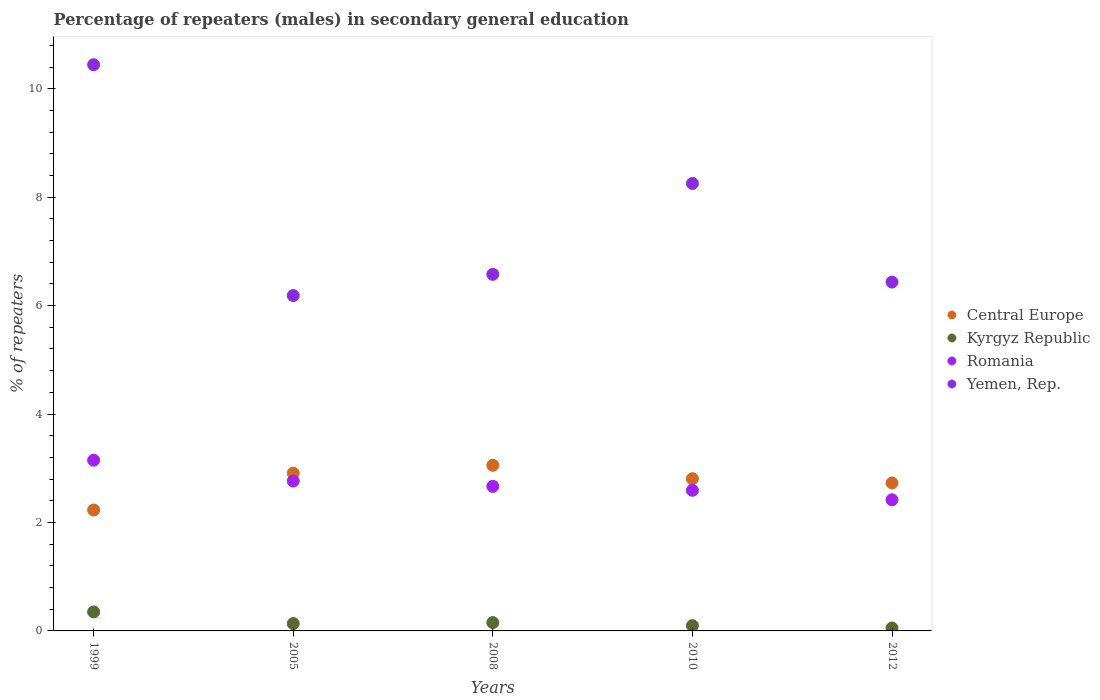What is the percentage of male repeaters in Yemen, Rep. in 2010?
Offer a terse response. 8.25. Across all years, what is the maximum percentage of male repeaters in Kyrgyz Republic?
Your answer should be very brief. 0.35. Across all years, what is the minimum percentage of male repeaters in Central Europe?
Keep it short and to the point. 2.23. In which year was the percentage of male repeaters in Central Europe maximum?
Ensure brevity in your answer.  2008. In which year was the percentage of male repeaters in Central Europe minimum?
Offer a very short reply. 1999. What is the total percentage of male repeaters in Central Europe in the graph?
Offer a terse response. 13.73. What is the difference between the percentage of male repeaters in Romania in 2008 and that in 2010?
Your answer should be very brief. 0.07. What is the difference between the percentage of male repeaters in Romania in 1999 and the percentage of male repeaters in Kyrgyz Republic in 2008?
Your answer should be compact. 3. What is the average percentage of male repeaters in Yemen, Rep. per year?
Ensure brevity in your answer.  7.58. In the year 2008, what is the difference between the percentage of male repeaters in Central Europe and percentage of male repeaters in Kyrgyz Republic?
Your answer should be compact. 2.9. In how many years, is the percentage of male repeaters in Yemen, Rep. greater than 7.6 %?
Make the answer very short. 2. What is the ratio of the percentage of male repeaters in Romania in 1999 to that in 2012?
Your answer should be compact. 1.3. Is the percentage of male repeaters in Kyrgyz Republic in 1999 less than that in 2012?
Make the answer very short. No. Is the difference between the percentage of male repeaters in Central Europe in 2010 and 2012 greater than the difference between the percentage of male repeaters in Kyrgyz Republic in 2010 and 2012?
Ensure brevity in your answer.  Yes. What is the difference between the highest and the second highest percentage of male repeaters in Kyrgyz Republic?
Make the answer very short. 0.2. What is the difference between the highest and the lowest percentage of male repeaters in Romania?
Provide a short and direct response. 0.73. In how many years, is the percentage of male repeaters in Kyrgyz Republic greater than the average percentage of male repeaters in Kyrgyz Republic taken over all years?
Give a very brief answer. 1. How many dotlines are there?
Provide a short and direct response. 4. Are the values on the major ticks of Y-axis written in scientific E-notation?
Give a very brief answer. No. Where does the legend appear in the graph?
Your response must be concise. Center right. How many legend labels are there?
Give a very brief answer. 4. What is the title of the graph?
Ensure brevity in your answer.  Percentage of repeaters (males) in secondary general education. What is the label or title of the X-axis?
Your answer should be compact. Years. What is the label or title of the Y-axis?
Make the answer very short. % of repeaters. What is the % of repeaters in Central Europe in 1999?
Give a very brief answer. 2.23. What is the % of repeaters of Kyrgyz Republic in 1999?
Provide a succinct answer. 0.35. What is the % of repeaters in Romania in 1999?
Your answer should be compact. 3.15. What is the % of repeaters in Yemen, Rep. in 1999?
Make the answer very short. 10.44. What is the % of repeaters of Central Europe in 2005?
Make the answer very short. 2.91. What is the % of repeaters of Kyrgyz Republic in 2005?
Your answer should be compact. 0.14. What is the % of repeaters in Romania in 2005?
Your answer should be compact. 2.76. What is the % of repeaters of Yemen, Rep. in 2005?
Offer a terse response. 6.19. What is the % of repeaters of Central Europe in 2008?
Keep it short and to the point. 3.05. What is the % of repeaters of Kyrgyz Republic in 2008?
Give a very brief answer. 0.15. What is the % of repeaters in Romania in 2008?
Your answer should be compact. 2.67. What is the % of repeaters in Yemen, Rep. in 2008?
Give a very brief answer. 6.58. What is the % of repeaters of Central Europe in 2010?
Your answer should be very brief. 2.81. What is the % of repeaters in Kyrgyz Republic in 2010?
Give a very brief answer. 0.1. What is the % of repeaters in Romania in 2010?
Your answer should be very brief. 2.59. What is the % of repeaters in Yemen, Rep. in 2010?
Your answer should be very brief. 8.25. What is the % of repeaters in Central Europe in 2012?
Your answer should be compact. 2.73. What is the % of repeaters of Kyrgyz Republic in 2012?
Provide a succinct answer. 0.05. What is the % of repeaters of Romania in 2012?
Provide a short and direct response. 2.42. What is the % of repeaters of Yemen, Rep. in 2012?
Your answer should be compact. 6.43. Across all years, what is the maximum % of repeaters of Central Europe?
Your answer should be compact. 3.05. Across all years, what is the maximum % of repeaters in Kyrgyz Republic?
Offer a terse response. 0.35. Across all years, what is the maximum % of repeaters of Romania?
Give a very brief answer. 3.15. Across all years, what is the maximum % of repeaters in Yemen, Rep.?
Give a very brief answer. 10.44. Across all years, what is the minimum % of repeaters in Central Europe?
Offer a very short reply. 2.23. Across all years, what is the minimum % of repeaters in Kyrgyz Republic?
Your response must be concise. 0.05. Across all years, what is the minimum % of repeaters in Romania?
Offer a very short reply. 2.42. Across all years, what is the minimum % of repeaters in Yemen, Rep.?
Your answer should be compact. 6.19. What is the total % of repeaters in Central Europe in the graph?
Provide a succinct answer. 13.73. What is the total % of repeaters in Kyrgyz Republic in the graph?
Make the answer very short. 0.79. What is the total % of repeaters in Romania in the graph?
Ensure brevity in your answer.  13.59. What is the total % of repeaters of Yemen, Rep. in the graph?
Provide a succinct answer. 37.89. What is the difference between the % of repeaters of Central Europe in 1999 and that in 2005?
Provide a short and direct response. -0.68. What is the difference between the % of repeaters of Kyrgyz Republic in 1999 and that in 2005?
Keep it short and to the point. 0.22. What is the difference between the % of repeaters of Romania in 1999 and that in 2005?
Offer a terse response. 0.39. What is the difference between the % of repeaters in Yemen, Rep. in 1999 and that in 2005?
Your response must be concise. 4.26. What is the difference between the % of repeaters in Central Europe in 1999 and that in 2008?
Keep it short and to the point. -0.83. What is the difference between the % of repeaters in Kyrgyz Republic in 1999 and that in 2008?
Provide a short and direct response. 0.2. What is the difference between the % of repeaters of Romania in 1999 and that in 2008?
Give a very brief answer. 0.48. What is the difference between the % of repeaters of Yemen, Rep. in 1999 and that in 2008?
Your answer should be very brief. 3.87. What is the difference between the % of repeaters of Central Europe in 1999 and that in 2010?
Provide a succinct answer. -0.58. What is the difference between the % of repeaters in Kyrgyz Republic in 1999 and that in 2010?
Provide a succinct answer. 0.25. What is the difference between the % of repeaters in Romania in 1999 and that in 2010?
Ensure brevity in your answer.  0.56. What is the difference between the % of repeaters of Yemen, Rep. in 1999 and that in 2010?
Your answer should be very brief. 2.19. What is the difference between the % of repeaters in Central Europe in 1999 and that in 2012?
Your answer should be very brief. -0.5. What is the difference between the % of repeaters in Kyrgyz Republic in 1999 and that in 2012?
Keep it short and to the point. 0.3. What is the difference between the % of repeaters of Romania in 1999 and that in 2012?
Your response must be concise. 0.73. What is the difference between the % of repeaters in Yemen, Rep. in 1999 and that in 2012?
Your response must be concise. 4.01. What is the difference between the % of repeaters of Central Europe in 2005 and that in 2008?
Offer a terse response. -0.15. What is the difference between the % of repeaters of Kyrgyz Republic in 2005 and that in 2008?
Your answer should be very brief. -0.02. What is the difference between the % of repeaters in Romania in 2005 and that in 2008?
Ensure brevity in your answer.  0.1. What is the difference between the % of repeaters in Yemen, Rep. in 2005 and that in 2008?
Your response must be concise. -0.39. What is the difference between the % of repeaters in Central Europe in 2005 and that in 2010?
Your answer should be very brief. 0.1. What is the difference between the % of repeaters of Kyrgyz Republic in 2005 and that in 2010?
Make the answer very short. 0.04. What is the difference between the % of repeaters in Romania in 2005 and that in 2010?
Provide a short and direct response. 0.17. What is the difference between the % of repeaters of Yemen, Rep. in 2005 and that in 2010?
Offer a terse response. -2.07. What is the difference between the % of repeaters in Central Europe in 2005 and that in 2012?
Provide a succinct answer. 0.18. What is the difference between the % of repeaters in Kyrgyz Republic in 2005 and that in 2012?
Your response must be concise. 0.08. What is the difference between the % of repeaters of Romania in 2005 and that in 2012?
Provide a short and direct response. 0.34. What is the difference between the % of repeaters in Yemen, Rep. in 2005 and that in 2012?
Your answer should be compact. -0.25. What is the difference between the % of repeaters in Central Europe in 2008 and that in 2010?
Your answer should be compact. 0.25. What is the difference between the % of repeaters in Kyrgyz Republic in 2008 and that in 2010?
Your response must be concise. 0.06. What is the difference between the % of repeaters of Romania in 2008 and that in 2010?
Provide a succinct answer. 0.07. What is the difference between the % of repeaters of Yemen, Rep. in 2008 and that in 2010?
Keep it short and to the point. -1.68. What is the difference between the % of repeaters in Central Europe in 2008 and that in 2012?
Your answer should be very brief. 0.33. What is the difference between the % of repeaters in Kyrgyz Republic in 2008 and that in 2012?
Make the answer very short. 0.1. What is the difference between the % of repeaters of Romania in 2008 and that in 2012?
Ensure brevity in your answer.  0.25. What is the difference between the % of repeaters of Yemen, Rep. in 2008 and that in 2012?
Ensure brevity in your answer.  0.14. What is the difference between the % of repeaters in Central Europe in 2010 and that in 2012?
Provide a short and direct response. 0.08. What is the difference between the % of repeaters of Kyrgyz Republic in 2010 and that in 2012?
Give a very brief answer. 0.04. What is the difference between the % of repeaters of Romania in 2010 and that in 2012?
Your answer should be very brief. 0.17. What is the difference between the % of repeaters in Yemen, Rep. in 2010 and that in 2012?
Your answer should be very brief. 1.82. What is the difference between the % of repeaters in Central Europe in 1999 and the % of repeaters in Kyrgyz Republic in 2005?
Keep it short and to the point. 2.09. What is the difference between the % of repeaters of Central Europe in 1999 and the % of repeaters of Romania in 2005?
Give a very brief answer. -0.53. What is the difference between the % of repeaters in Central Europe in 1999 and the % of repeaters in Yemen, Rep. in 2005?
Give a very brief answer. -3.96. What is the difference between the % of repeaters in Kyrgyz Republic in 1999 and the % of repeaters in Romania in 2005?
Give a very brief answer. -2.41. What is the difference between the % of repeaters in Kyrgyz Republic in 1999 and the % of repeaters in Yemen, Rep. in 2005?
Provide a succinct answer. -5.84. What is the difference between the % of repeaters in Romania in 1999 and the % of repeaters in Yemen, Rep. in 2005?
Give a very brief answer. -3.04. What is the difference between the % of repeaters in Central Europe in 1999 and the % of repeaters in Kyrgyz Republic in 2008?
Ensure brevity in your answer.  2.08. What is the difference between the % of repeaters of Central Europe in 1999 and the % of repeaters of Romania in 2008?
Ensure brevity in your answer.  -0.44. What is the difference between the % of repeaters of Central Europe in 1999 and the % of repeaters of Yemen, Rep. in 2008?
Provide a short and direct response. -4.35. What is the difference between the % of repeaters in Kyrgyz Republic in 1999 and the % of repeaters in Romania in 2008?
Provide a succinct answer. -2.32. What is the difference between the % of repeaters of Kyrgyz Republic in 1999 and the % of repeaters of Yemen, Rep. in 2008?
Your answer should be compact. -6.23. What is the difference between the % of repeaters of Romania in 1999 and the % of repeaters of Yemen, Rep. in 2008?
Give a very brief answer. -3.43. What is the difference between the % of repeaters of Central Europe in 1999 and the % of repeaters of Kyrgyz Republic in 2010?
Ensure brevity in your answer.  2.13. What is the difference between the % of repeaters of Central Europe in 1999 and the % of repeaters of Romania in 2010?
Make the answer very short. -0.36. What is the difference between the % of repeaters of Central Europe in 1999 and the % of repeaters of Yemen, Rep. in 2010?
Ensure brevity in your answer.  -6.02. What is the difference between the % of repeaters of Kyrgyz Republic in 1999 and the % of repeaters of Romania in 2010?
Make the answer very short. -2.24. What is the difference between the % of repeaters of Kyrgyz Republic in 1999 and the % of repeaters of Yemen, Rep. in 2010?
Provide a short and direct response. -7.9. What is the difference between the % of repeaters of Romania in 1999 and the % of repeaters of Yemen, Rep. in 2010?
Offer a very short reply. -5.1. What is the difference between the % of repeaters of Central Europe in 1999 and the % of repeaters of Kyrgyz Republic in 2012?
Provide a succinct answer. 2.18. What is the difference between the % of repeaters in Central Europe in 1999 and the % of repeaters in Romania in 2012?
Provide a succinct answer. -0.19. What is the difference between the % of repeaters of Central Europe in 1999 and the % of repeaters of Yemen, Rep. in 2012?
Provide a short and direct response. -4.2. What is the difference between the % of repeaters in Kyrgyz Republic in 1999 and the % of repeaters in Romania in 2012?
Keep it short and to the point. -2.07. What is the difference between the % of repeaters in Kyrgyz Republic in 1999 and the % of repeaters in Yemen, Rep. in 2012?
Your response must be concise. -6.08. What is the difference between the % of repeaters in Romania in 1999 and the % of repeaters in Yemen, Rep. in 2012?
Offer a very short reply. -3.29. What is the difference between the % of repeaters in Central Europe in 2005 and the % of repeaters in Kyrgyz Republic in 2008?
Make the answer very short. 2.76. What is the difference between the % of repeaters of Central Europe in 2005 and the % of repeaters of Romania in 2008?
Provide a succinct answer. 0.24. What is the difference between the % of repeaters in Central Europe in 2005 and the % of repeaters in Yemen, Rep. in 2008?
Your answer should be compact. -3.67. What is the difference between the % of repeaters in Kyrgyz Republic in 2005 and the % of repeaters in Romania in 2008?
Your response must be concise. -2.53. What is the difference between the % of repeaters of Kyrgyz Republic in 2005 and the % of repeaters of Yemen, Rep. in 2008?
Provide a succinct answer. -6.44. What is the difference between the % of repeaters of Romania in 2005 and the % of repeaters of Yemen, Rep. in 2008?
Your answer should be very brief. -3.81. What is the difference between the % of repeaters in Central Europe in 2005 and the % of repeaters in Kyrgyz Republic in 2010?
Ensure brevity in your answer.  2.81. What is the difference between the % of repeaters in Central Europe in 2005 and the % of repeaters in Romania in 2010?
Your response must be concise. 0.32. What is the difference between the % of repeaters of Central Europe in 2005 and the % of repeaters of Yemen, Rep. in 2010?
Your answer should be very brief. -5.34. What is the difference between the % of repeaters of Kyrgyz Republic in 2005 and the % of repeaters of Romania in 2010?
Provide a succinct answer. -2.46. What is the difference between the % of repeaters of Kyrgyz Republic in 2005 and the % of repeaters of Yemen, Rep. in 2010?
Offer a terse response. -8.12. What is the difference between the % of repeaters in Romania in 2005 and the % of repeaters in Yemen, Rep. in 2010?
Provide a succinct answer. -5.49. What is the difference between the % of repeaters in Central Europe in 2005 and the % of repeaters in Kyrgyz Republic in 2012?
Keep it short and to the point. 2.85. What is the difference between the % of repeaters in Central Europe in 2005 and the % of repeaters in Romania in 2012?
Your answer should be very brief. 0.49. What is the difference between the % of repeaters of Central Europe in 2005 and the % of repeaters of Yemen, Rep. in 2012?
Your answer should be compact. -3.52. What is the difference between the % of repeaters in Kyrgyz Republic in 2005 and the % of repeaters in Romania in 2012?
Your answer should be very brief. -2.28. What is the difference between the % of repeaters in Kyrgyz Republic in 2005 and the % of repeaters in Yemen, Rep. in 2012?
Give a very brief answer. -6.3. What is the difference between the % of repeaters of Romania in 2005 and the % of repeaters of Yemen, Rep. in 2012?
Make the answer very short. -3.67. What is the difference between the % of repeaters of Central Europe in 2008 and the % of repeaters of Kyrgyz Republic in 2010?
Your answer should be compact. 2.96. What is the difference between the % of repeaters of Central Europe in 2008 and the % of repeaters of Romania in 2010?
Provide a succinct answer. 0.46. What is the difference between the % of repeaters in Central Europe in 2008 and the % of repeaters in Yemen, Rep. in 2010?
Your answer should be very brief. -5.2. What is the difference between the % of repeaters of Kyrgyz Republic in 2008 and the % of repeaters of Romania in 2010?
Give a very brief answer. -2.44. What is the difference between the % of repeaters in Kyrgyz Republic in 2008 and the % of repeaters in Yemen, Rep. in 2010?
Provide a succinct answer. -8.1. What is the difference between the % of repeaters in Romania in 2008 and the % of repeaters in Yemen, Rep. in 2010?
Your answer should be very brief. -5.59. What is the difference between the % of repeaters of Central Europe in 2008 and the % of repeaters of Kyrgyz Republic in 2012?
Ensure brevity in your answer.  3. What is the difference between the % of repeaters in Central Europe in 2008 and the % of repeaters in Romania in 2012?
Keep it short and to the point. 0.64. What is the difference between the % of repeaters in Central Europe in 2008 and the % of repeaters in Yemen, Rep. in 2012?
Offer a terse response. -3.38. What is the difference between the % of repeaters in Kyrgyz Republic in 2008 and the % of repeaters in Romania in 2012?
Provide a short and direct response. -2.27. What is the difference between the % of repeaters in Kyrgyz Republic in 2008 and the % of repeaters in Yemen, Rep. in 2012?
Provide a succinct answer. -6.28. What is the difference between the % of repeaters of Romania in 2008 and the % of repeaters of Yemen, Rep. in 2012?
Your response must be concise. -3.77. What is the difference between the % of repeaters in Central Europe in 2010 and the % of repeaters in Kyrgyz Republic in 2012?
Your answer should be very brief. 2.75. What is the difference between the % of repeaters of Central Europe in 2010 and the % of repeaters of Romania in 2012?
Make the answer very short. 0.39. What is the difference between the % of repeaters of Central Europe in 2010 and the % of repeaters of Yemen, Rep. in 2012?
Your answer should be very brief. -3.63. What is the difference between the % of repeaters in Kyrgyz Republic in 2010 and the % of repeaters in Romania in 2012?
Give a very brief answer. -2.32. What is the difference between the % of repeaters of Kyrgyz Republic in 2010 and the % of repeaters of Yemen, Rep. in 2012?
Ensure brevity in your answer.  -6.34. What is the difference between the % of repeaters of Romania in 2010 and the % of repeaters of Yemen, Rep. in 2012?
Provide a succinct answer. -3.84. What is the average % of repeaters of Central Europe per year?
Ensure brevity in your answer.  2.75. What is the average % of repeaters in Kyrgyz Republic per year?
Your answer should be compact. 0.16. What is the average % of repeaters of Romania per year?
Ensure brevity in your answer.  2.72. What is the average % of repeaters in Yemen, Rep. per year?
Ensure brevity in your answer.  7.58. In the year 1999, what is the difference between the % of repeaters in Central Europe and % of repeaters in Kyrgyz Republic?
Offer a terse response. 1.88. In the year 1999, what is the difference between the % of repeaters of Central Europe and % of repeaters of Romania?
Make the answer very short. -0.92. In the year 1999, what is the difference between the % of repeaters of Central Europe and % of repeaters of Yemen, Rep.?
Your answer should be compact. -8.21. In the year 1999, what is the difference between the % of repeaters of Kyrgyz Republic and % of repeaters of Romania?
Make the answer very short. -2.8. In the year 1999, what is the difference between the % of repeaters of Kyrgyz Republic and % of repeaters of Yemen, Rep.?
Provide a succinct answer. -10.09. In the year 1999, what is the difference between the % of repeaters in Romania and % of repeaters in Yemen, Rep.?
Offer a terse response. -7.29. In the year 2005, what is the difference between the % of repeaters in Central Europe and % of repeaters in Kyrgyz Republic?
Ensure brevity in your answer.  2.77. In the year 2005, what is the difference between the % of repeaters of Central Europe and % of repeaters of Romania?
Keep it short and to the point. 0.15. In the year 2005, what is the difference between the % of repeaters in Central Europe and % of repeaters in Yemen, Rep.?
Your response must be concise. -3.28. In the year 2005, what is the difference between the % of repeaters of Kyrgyz Republic and % of repeaters of Romania?
Your response must be concise. -2.63. In the year 2005, what is the difference between the % of repeaters in Kyrgyz Republic and % of repeaters in Yemen, Rep.?
Give a very brief answer. -6.05. In the year 2005, what is the difference between the % of repeaters of Romania and % of repeaters of Yemen, Rep.?
Make the answer very short. -3.42. In the year 2008, what is the difference between the % of repeaters of Central Europe and % of repeaters of Kyrgyz Republic?
Offer a very short reply. 2.9. In the year 2008, what is the difference between the % of repeaters in Central Europe and % of repeaters in Romania?
Your answer should be very brief. 0.39. In the year 2008, what is the difference between the % of repeaters of Central Europe and % of repeaters of Yemen, Rep.?
Provide a succinct answer. -3.52. In the year 2008, what is the difference between the % of repeaters of Kyrgyz Republic and % of repeaters of Romania?
Ensure brevity in your answer.  -2.51. In the year 2008, what is the difference between the % of repeaters in Kyrgyz Republic and % of repeaters in Yemen, Rep.?
Give a very brief answer. -6.42. In the year 2008, what is the difference between the % of repeaters in Romania and % of repeaters in Yemen, Rep.?
Make the answer very short. -3.91. In the year 2010, what is the difference between the % of repeaters in Central Europe and % of repeaters in Kyrgyz Republic?
Offer a terse response. 2.71. In the year 2010, what is the difference between the % of repeaters in Central Europe and % of repeaters in Romania?
Offer a very short reply. 0.21. In the year 2010, what is the difference between the % of repeaters of Central Europe and % of repeaters of Yemen, Rep.?
Provide a short and direct response. -5.45. In the year 2010, what is the difference between the % of repeaters in Kyrgyz Republic and % of repeaters in Romania?
Offer a very short reply. -2.5. In the year 2010, what is the difference between the % of repeaters in Kyrgyz Republic and % of repeaters in Yemen, Rep.?
Your answer should be very brief. -8.16. In the year 2010, what is the difference between the % of repeaters of Romania and % of repeaters of Yemen, Rep.?
Give a very brief answer. -5.66. In the year 2012, what is the difference between the % of repeaters of Central Europe and % of repeaters of Kyrgyz Republic?
Your answer should be very brief. 2.67. In the year 2012, what is the difference between the % of repeaters in Central Europe and % of repeaters in Romania?
Offer a very short reply. 0.31. In the year 2012, what is the difference between the % of repeaters in Central Europe and % of repeaters in Yemen, Rep.?
Your response must be concise. -3.71. In the year 2012, what is the difference between the % of repeaters of Kyrgyz Republic and % of repeaters of Romania?
Provide a succinct answer. -2.36. In the year 2012, what is the difference between the % of repeaters in Kyrgyz Republic and % of repeaters in Yemen, Rep.?
Keep it short and to the point. -6.38. In the year 2012, what is the difference between the % of repeaters of Romania and % of repeaters of Yemen, Rep.?
Give a very brief answer. -4.02. What is the ratio of the % of repeaters of Central Europe in 1999 to that in 2005?
Offer a terse response. 0.77. What is the ratio of the % of repeaters of Kyrgyz Republic in 1999 to that in 2005?
Give a very brief answer. 2.59. What is the ratio of the % of repeaters in Romania in 1999 to that in 2005?
Your answer should be compact. 1.14. What is the ratio of the % of repeaters of Yemen, Rep. in 1999 to that in 2005?
Offer a terse response. 1.69. What is the ratio of the % of repeaters of Central Europe in 1999 to that in 2008?
Your response must be concise. 0.73. What is the ratio of the % of repeaters of Kyrgyz Republic in 1999 to that in 2008?
Your response must be concise. 2.28. What is the ratio of the % of repeaters in Romania in 1999 to that in 2008?
Offer a terse response. 1.18. What is the ratio of the % of repeaters of Yemen, Rep. in 1999 to that in 2008?
Ensure brevity in your answer.  1.59. What is the ratio of the % of repeaters of Central Europe in 1999 to that in 2010?
Provide a short and direct response. 0.79. What is the ratio of the % of repeaters in Kyrgyz Republic in 1999 to that in 2010?
Ensure brevity in your answer.  3.61. What is the ratio of the % of repeaters in Romania in 1999 to that in 2010?
Give a very brief answer. 1.21. What is the ratio of the % of repeaters of Yemen, Rep. in 1999 to that in 2010?
Your response must be concise. 1.27. What is the ratio of the % of repeaters of Central Europe in 1999 to that in 2012?
Keep it short and to the point. 0.82. What is the ratio of the % of repeaters in Kyrgyz Republic in 1999 to that in 2012?
Your answer should be very brief. 6.42. What is the ratio of the % of repeaters of Romania in 1999 to that in 2012?
Your answer should be compact. 1.3. What is the ratio of the % of repeaters of Yemen, Rep. in 1999 to that in 2012?
Make the answer very short. 1.62. What is the ratio of the % of repeaters in Central Europe in 2005 to that in 2008?
Ensure brevity in your answer.  0.95. What is the ratio of the % of repeaters of Kyrgyz Republic in 2005 to that in 2008?
Give a very brief answer. 0.88. What is the ratio of the % of repeaters of Romania in 2005 to that in 2008?
Make the answer very short. 1.04. What is the ratio of the % of repeaters in Yemen, Rep. in 2005 to that in 2008?
Provide a succinct answer. 0.94. What is the ratio of the % of repeaters of Central Europe in 2005 to that in 2010?
Give a very brief answer. 1.04. What is the ratio of the % of repeaters of Kyrgyz Republic in 2005 to that in 2010?
Provide a short and direct response. 1.39. What is the ratio of the % of repeaters of Romania in 2005 to that in 2010?
Give a very brief answer. 1.07. What is the ratio of the % of repeaters in Yemen, Rep. in 2005 to that in 2010?
Your response must be concise. 0.75. What is the ratio of the % of repeaters of Central Europe in 2005 to that in 2012?
Your answer should be compact. 1.07. What is the ratio of the % of repeaters in Kyrgyz Republic in 2005 to that in 2012?
Offer a terse response. 2.48. What is the ratio of the % of repeaters in Romania in 2005 to that in 2012?
Ensure brevity in your answer.  1.14. What is the ratio of the % of repeaters of Yemen, Rep. in 2005 to that in 2012?
Your answer should be compact. 0.96. What is the ratio of the % of repeaters of Central Europe in 2008 to that in 2010?
Your answer should be very brief. 1.09. What is the ratio of the % of repeaters of Kyrgyz Republic in 2008 to that in 2010?
Ensure brevity in your answer.  1.58. What is the ratio of the % of repeaters of Romania in 2008 to that in 2010?
Your answer should be very brief. 1.03. What is the ratio of the % of repeaters in Yemen, Rep. in 2008 to that in 2010?
Offer a very short reply. 0.8. What is the ratio of the % of repeaters in Central Europe in 2008 to that in 2012?
Offer a terse response. 1.12. What is the ratio of the % of repeaters of Kyrgyz Republic in 2008 to that in 2012?
Your response must be concise. 2.82. What is the ratio of the % of repeaters of Romania in 2008 to that in 2012?
Ensure brevity in your answer.  1.1. What is the ratio of the % of repeaters of Yemen, Rep. in 2008 to that in 2012?
Make the answer very short. 1.02. What is the ratio of the % of repeaters in Central Europe in 2010 to that in 2012?
Provide a short and direct response. 1.03. What is the ratio of the % of repeaters in Kyrgyz Republic in 2010 to that in 2012?
Provide a short and direct response. 1.78. What is the ratio of the % of repeaters in Romania in 2010 to that in 2012?
Provide a short and direct response. 1.07. What is the ratio of the % of repeaters of Yemen, Rep. in 2010 to that in 2012?
Offer a very short reply. 1.28. What is the difference between the highest and the second highest % of repeaters of Central Europe?
Ensure brevity in your answer.  0.15. What is the difference between the highest and the second highest % of repeaters in Kyrgyz Republic?
Keep it short and to the point. 0.2. What is the difference between the highest and the second highest % of repeaters of Romania?
Make the answer very short. 0.39. What is the difference between the highest and the second highest % of repeaters in Yemen, Rep.?
Ensure brevity in your answer.  2.19. What is the difference between the highest and the lowest % of repeaters in Central Europe?
Your answer should be compact. 0.83. What is the difference between the highest and the lowest % of repeaters in Kyrgyz Republic?
Your answer should be compact. 0.3. What is the difference between the highest and the lowest % of repeaters of Romania?
Provide a short and direct response. 0.73. What is the difference between the highest and the lowest % of repeaters of Yemen, Rep.?
Provide a succinct answer. 4.26. 